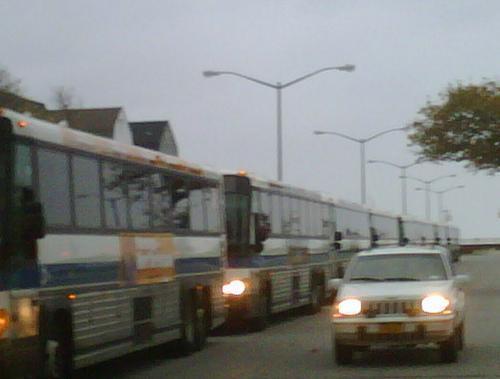How many vehicles are not busses?
Give a very brief answer. 1. How many trees are full of leaves?
Give a very brief answer. 1. 